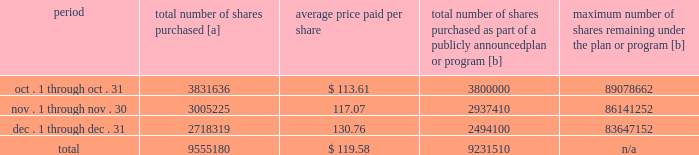Five-year performance comparison 2013 the following graph provides an indicator of cumulative total shareholder returns for the corporation as compared to the peer group index ( described above ) , the dj trans , and the s&p 500 .
The graph assumes that $ 100 was invested in the common stock of union pacific corporation and each index on december 31 , 2012 and that all dividends were reinvested .
The information below is historical in nature and is not necessarily indicative of future performance .
Purchases of equity securities 2013 during 2017 , we repurchased 37122405 shares of our common stock at an average price of $ 110.50 .
The table presents common stock repurchases during each month for the fourth quarter of 2017 : period total number of shares purchased [a] average price paid per share total number of shares purchased as part of a publicly announced plan or program [b] maximum number of shares remaining under the plan or program [b] .
[a] total number of shares purchased during the quarter includes approximately 323670 shares delivered or attested to upc by employees to pay stock option exercise prices , satisfy excess tax withholding obligations for stock option exercises or vesting of retention units , and pay withholding obligations for vesting of retention shares .
[b] effective january 1 , 2017 , our board of directors authorized the repurchase of up to 120 million shares of our common stock by december 31 , 2020 .
These repurchases may be made on the open market or through other transactions .
Our management has sole discretion with respect to determining the timing and amount of these transactions. .
What percent of the total shares purchased during the fourth quarter of 2017 were purchased in november? 
Computations: (3005225 / 9555180)
Answer: 0.31451. 